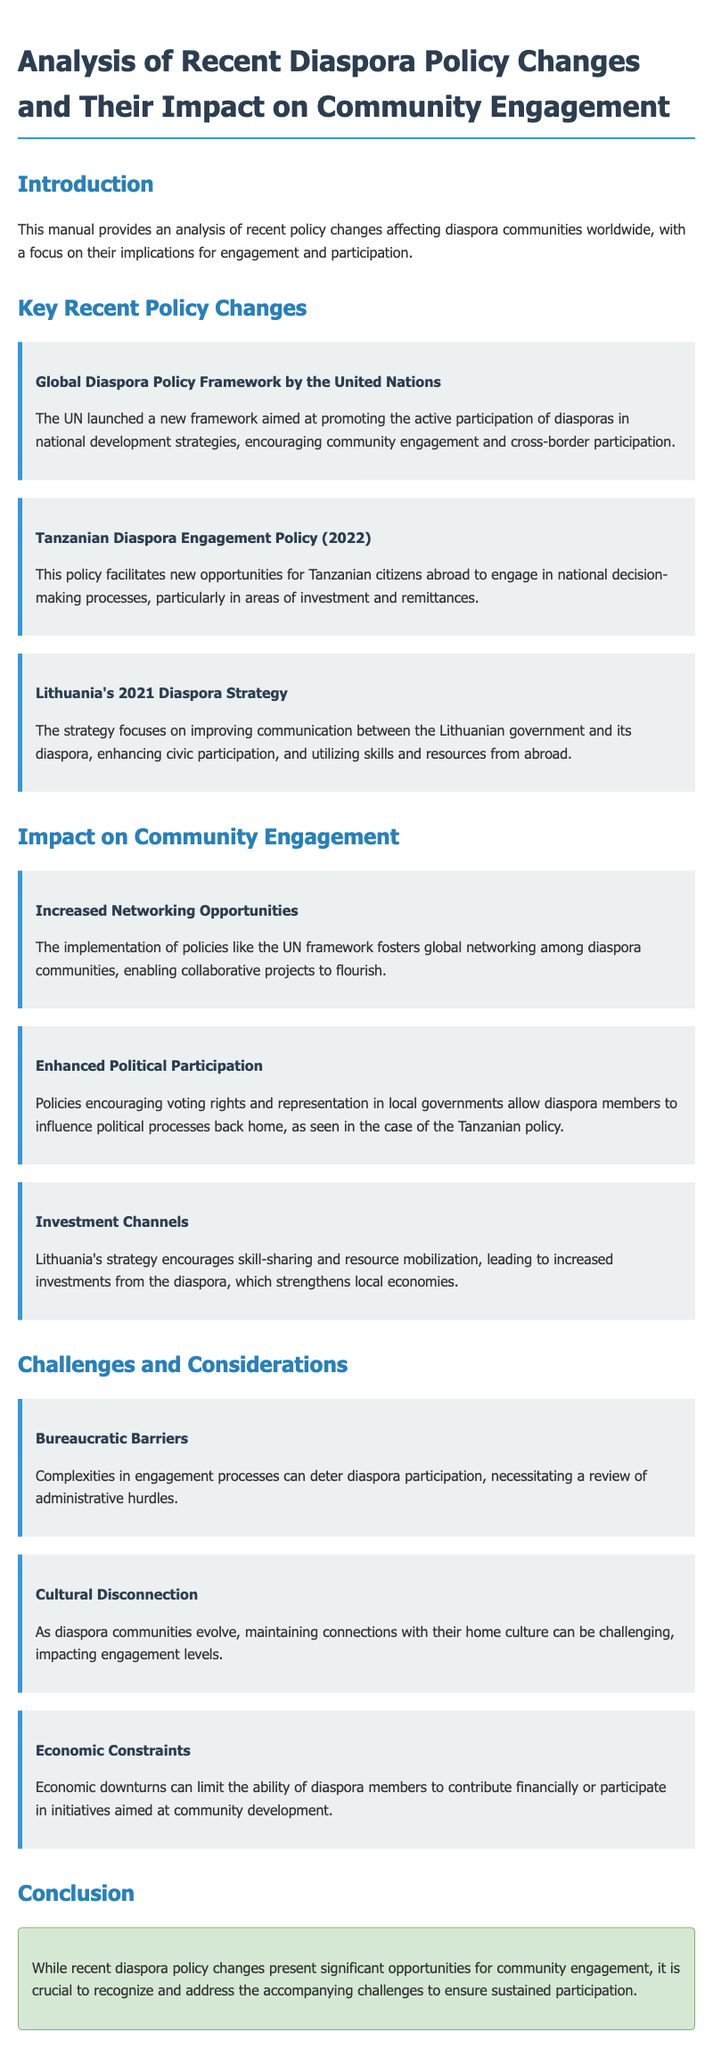what is the title of the manual? The title is stated in the heading of the document.
Answer: Analysis of Recent Diaspora Policy Changes and Their Impact on Community Engagement what organization launched the Global Diaspora Policy Framework? The organization responsible for the framework is mentioned in the document.
Answer: United Nations which year was the Tanzanian Diaspora Engagement Policy introduced? The year is specified in the description of the policy.
Answer: 2022 what is one impact of the Lithuanian strategy mentioned in the document? The document discusses various impacts, including one related to investment.
Answer: Increased investments from the diaspora name one challenge faced by diaspora communities according to the document. The challenges outlined in the document include several aspects affecting diaspora engagement.
Answer: Bureaucratic Barriers what is the focus of Lithuania's 2021 Diaspora Strategy? The focus of the strategy is described in detail.
Answer: Improving communication between the Lithuanian government and its diaspora how does the UN framework aim to support diasporas? The manual describes the aim of the framework related to diaspora participation.
Answer: Promoting active participation in national development strategies what aspect of community engagement does the manual highlight as enhanced? The manual mentions aspects of engagement that have been improved due to policy changes.
Answer: Political Participation 